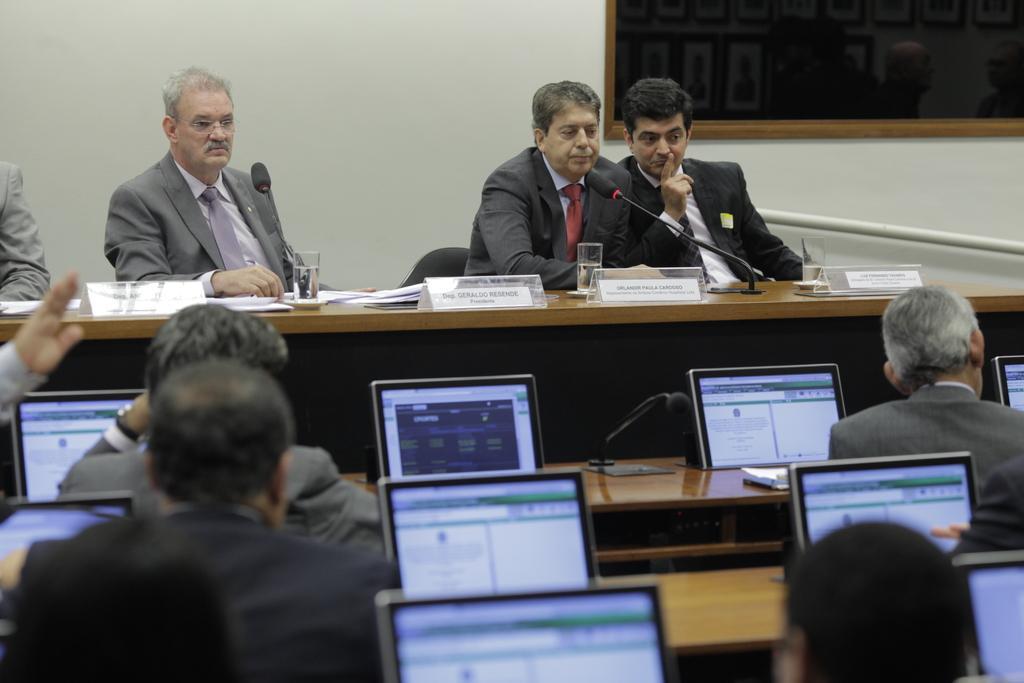Describe this image in one or two sentences. In the picture I can see glasses, papers and some text boards on the table. I can see two people holding the microphone. I can see laptops and people. 